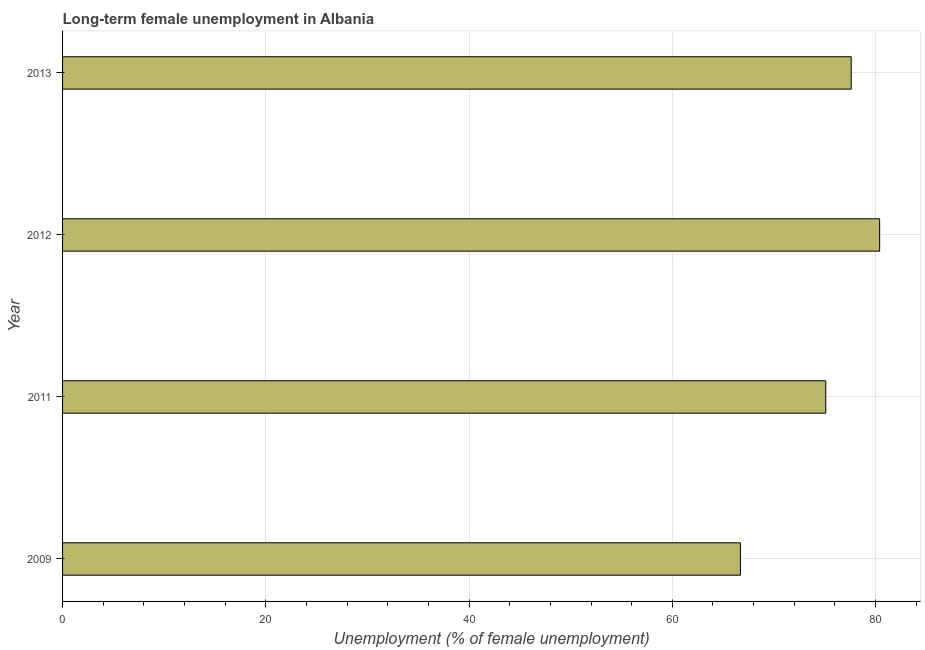Does the graph contain grids?
Your answer should be very brief. Yes. What is the title of the graph?
Make the answer very short. Long-term female unemployment in Albania. What is the label or title of the X-axis?
Your answer should be compact. Unemployment (% of female unemployment). What is the long-term female unemployment in 2011?
Ensure brevity in your answer.  75.1. Across all years, what is the maximum long-term female unemployment?
Offer a very short reply. 80.4. Across all years, what is the minimum long-term female unemployment?
Make the answer very short. 66.7. What is the sum of the long-term female unemployment?
Offer a very short reply. 299.8. What is the difference between the long-term female unemployment in 2009 and 2012?
Provide a short and direct response. -13.7. What is the average long-term female unemployment per year?
Make the answer very short. 74.95. What is the median long-term female unemployment?
Make the answer very short. 76.35. In how many years, is the long-term female unemployment greater than 20 %?
Offer a very short reply. 4. Do a majority of the years between 2011 and 2013 (inclusive) have long-term female unemployment greater than 68 %?
Give a very brief answer. Yes. What is the ratio of the long-term female unemployment in 2012 to that in 2013?
Keep it short and to the point. 1.04. Is the long-term female unemployment in 2009 less than that in 2011?
Your answer should be compact. Yes. Is the difference between the long-term female unemployment in 2009 and 2011 greater than the difference between any two years?
Offer a terse response. No. What is the difference between the highest and the lowest long-term female unemployment?
Offer a terse response. 13.7. Are all the bars in the graph horizontal?
Keep it short and to the point. Yes. How many years are there in the graph?
Give a very brief answer. 4. What is the Unemployment (% of female unemployment) of 2009?
Your answer should be very brief. 66.7. What is the Unemployment (% of female unemployment) in 2011?
Make the answer very short. 75.1. What is the Unemployment (% of female unemployment) of 2012?
Your answer should be compact. 80.4. What is the Unemployment (% of female unemployment) of 2013?
Ensure brevity in your answer.  77.6. What is the difference between the Unemployment (% of female unemployment) in 2009 and 2012?
Make the answer very short. -13.7. What is the ratio of the Unemployment (% of female unemployment) in 2009 to that in 2011?
Provide a short and direct response. 0.89. What is the ratio of the Unemployment (% of female unemployment) in 2009 to that in 2012?
Provide a short and direct response. 0.83. What is the ratio of the Unemployment (% of female unemployment) in 2009 to that in 2013?
Provide a succinct answer. 0.86. What is the ratio of the Unemployment (% of female unemployment) in 2011 to that in 2012?
Ensure brevity in your answer.  0.93. What is the ratio of the Unemployment (% of female unemployment) in 2012 to that in 2013?
Provide a succinct answer. 1.04. 